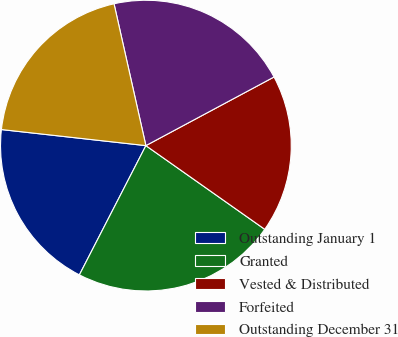Convert chart. <chart><loc_0><loc_0><loc_500><loc_500><pie_chart><fcel>Outstanding January 1<fcel>Granted<fcel>Vested & Distributed<fcel>Forfeited<fcel>Outstanding December 31<nl><fcel>19.2%<fcel>22.8%<fcel>17.59%<fcel>20.69%<fcel>19.72%<nl></chart> 